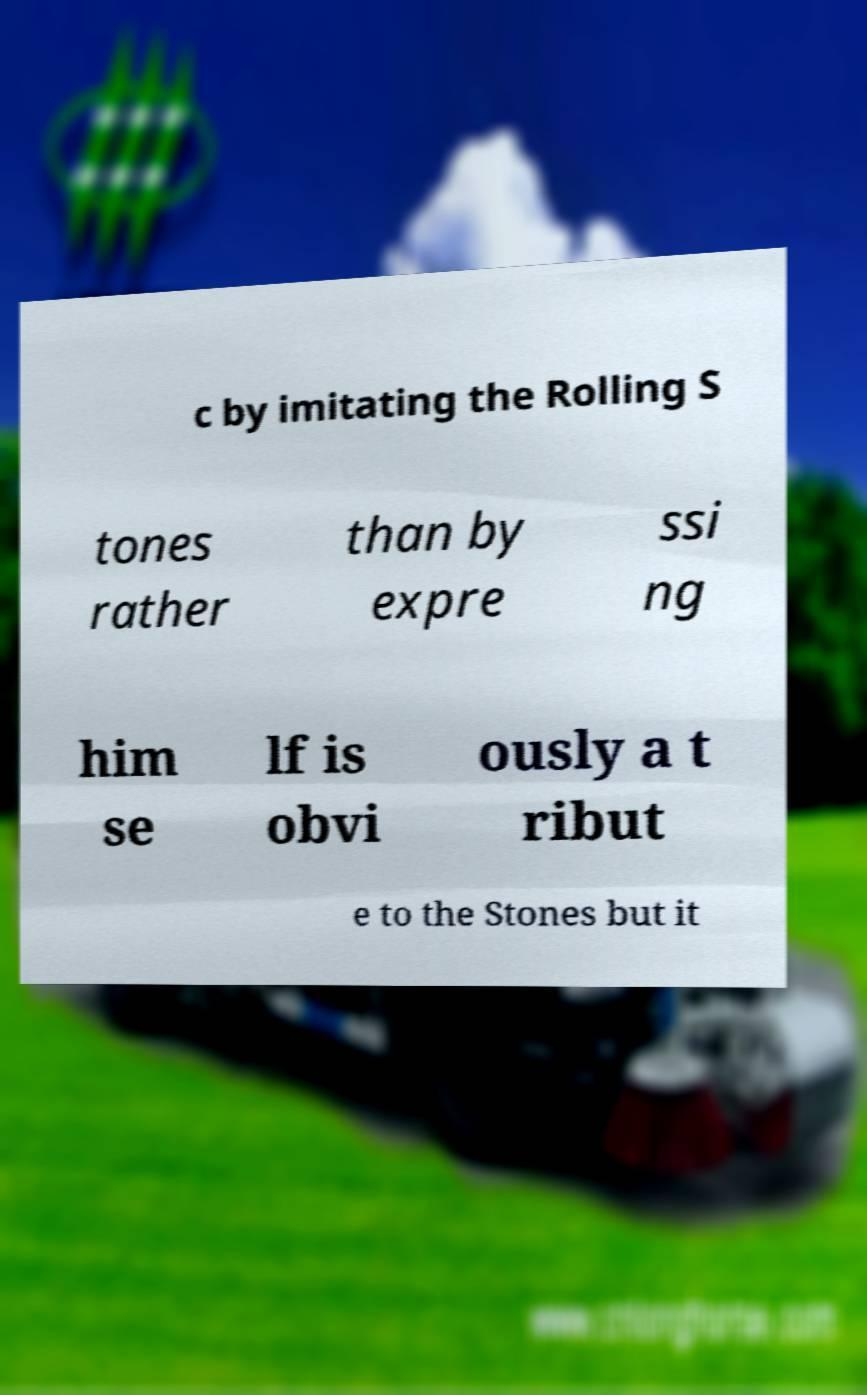There's text embedded in this image that I need extracted. Can you transcribe it verbatim? c by imitating the Rolling S tones rather than by expre ssi ng him se lf is obvi ously a t ribut e to the Stones but it 